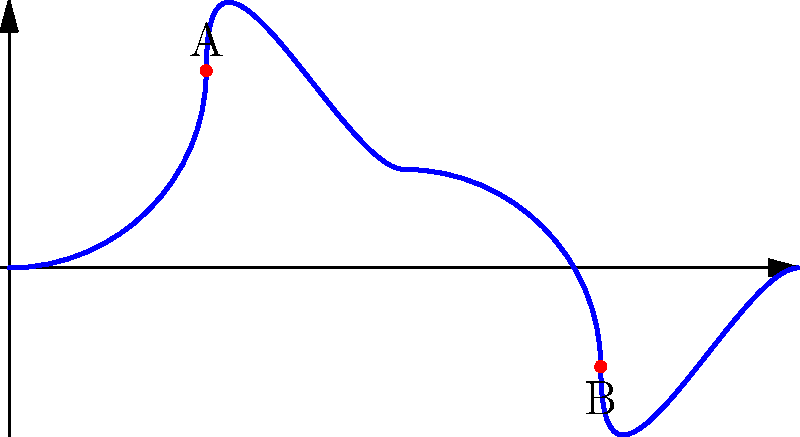In your summer landscape photograph of a meandering river, you observe two distinct points A and B along the river's path, as shown in the diagram. If the Euclidean distance between these points is 2 units, what is the minimum possible length of the river path connecting A and B? To determine the minimum possible length of the river path connecting points A and B, we need to follow these steps:

1. Recognize that the Euclidean distance between A and B (2 units) represents the straight-line distance between these points.

2. Understand that the river path between A and B must be at least as long as the straight-line distance, due to the meandering nature of the river.

3. Recall the topological concept of path length: The shortest path between two points in a topological space is the geodesic, which in Euclidean space is a straight line.

4. Consider that any deviation from the straight line (i.e., meandering) will increase the path length.

5. Conclude that the minimum possible length of the river path occurs when the river follows the straight line between A and B.

Therefore, the minimum possible length of the river path connecting A and B is equal to the Euclidean distance between these points, which is 2 units.
Answer: 2 units 